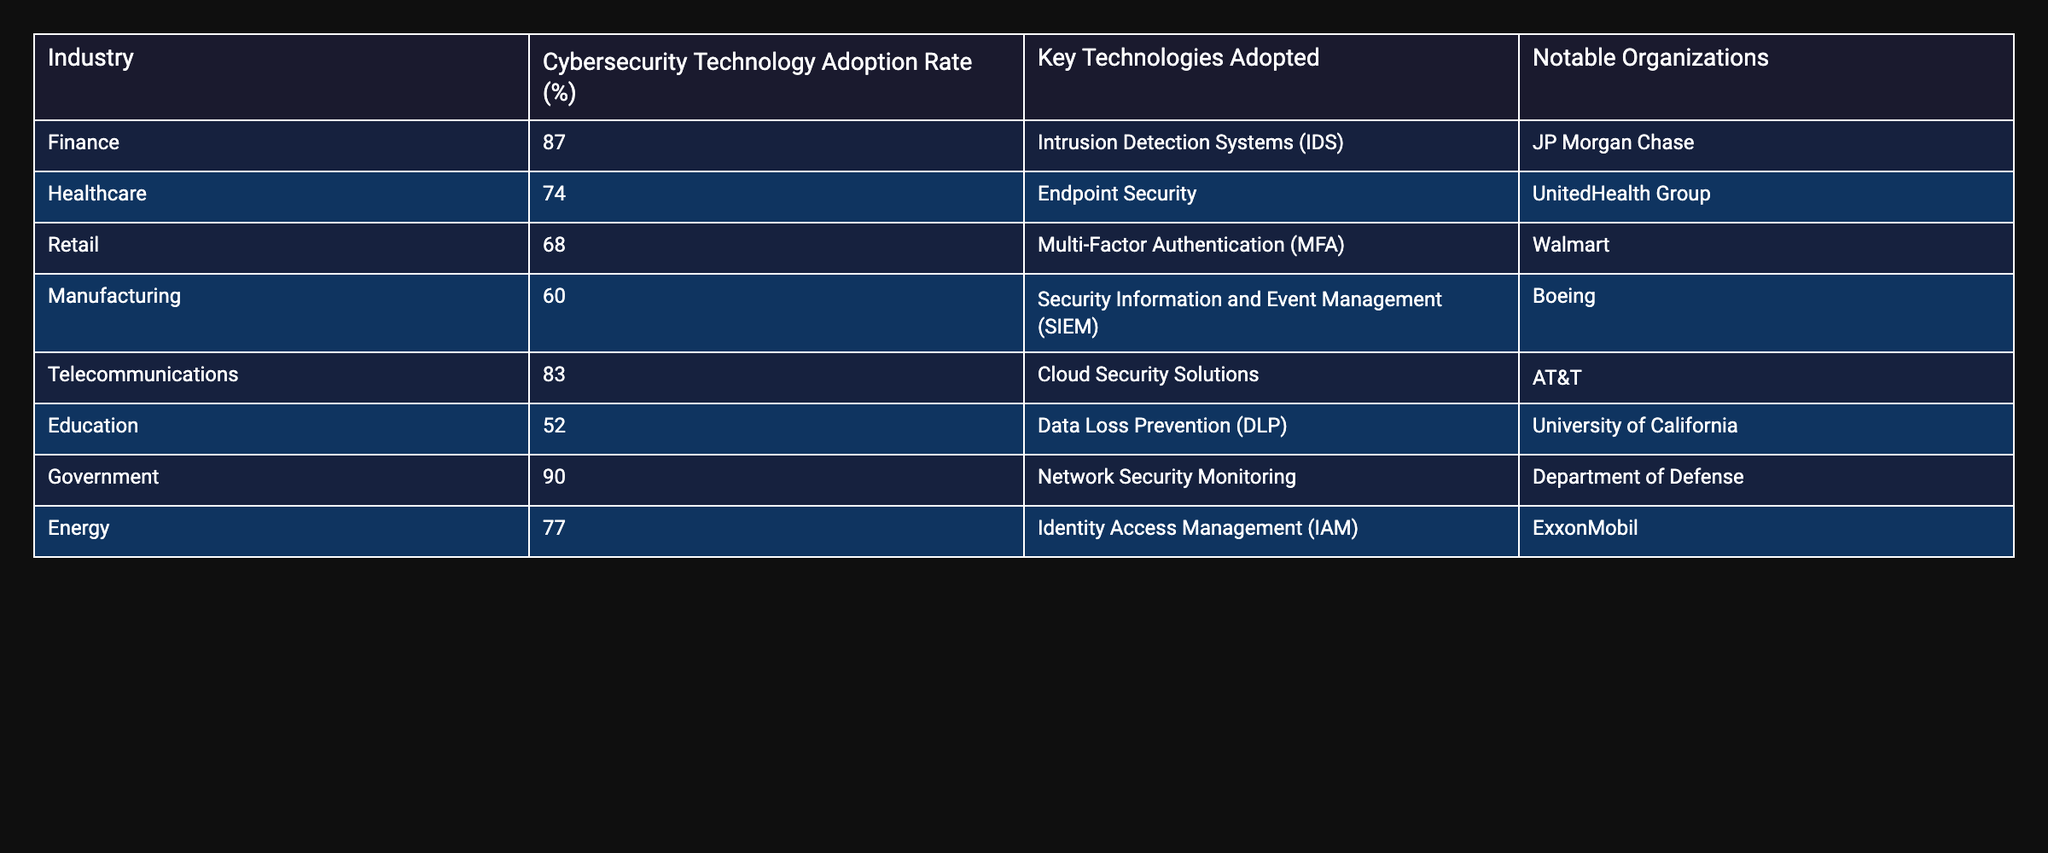What is the Cybersecurity Technology Adoption Rate for the Government industry? The table lists the adoption rate as 90% specifically for the Government industry.
Answer: 90% Which industry has the lowest Cybersecurity Technology Adoption Rate? The Education industry exhibits the lowest adoption rate at 52%, as shown by the data in the table.
Answer: 52% What is the average Cybersecurity Technology Adoption Rate across all industries listed? To calculate the average, sum the adoption rates: (87 + 74 + 68 + 60 + 83 + 52 + 90 + 77) = 601. There are 8 industries, so the average is 601 divided by 8, which equals 75.125.
Answer: 75.125 Is the use of Multi-Factor Authentication (MFA) more common in the Retail industry than Endpoint Security in Healthcare? The Retail industry has a 68% adoption rate for MFA, while Healthcare has a 74% adoption rate for Endpoint Security. Thus, it is false that MFA is more common than Endpoint Security in Healthcare.
Answer: No How many industries have an adoption rate above 80%? By examining the table, the Finance (87%), Telecommunications (83%), and Government (90%) industries have rates above 80%. Therefore, there are three industries.
Answer: 3 Which industry adopted Security Information and Event Management (SIEM) technology? The Manufacturing industry has adopted Security Information and Event Management (SIEM) technology, as seen in the specific key technologies listed in the table.
Answer: Manufacturing What percentage difference in Cybersecurity Technology Adoption Rate exists between Finance and Education? The Finance industry has a 87% adoption rate and Education has 52%. The difference is 87 - 52 = 35%. Therefore, the percentage difference is 35%.
Answer: 35% Which key technology is associated with the highest adoption rate and what is that rate? The key technology with the highest adoption rate is Network Security Monitoring, which is associated with the Government industry at a rate of 90%.
Answer: Network Security Monitoring, 90% Is Identity Access Management (IAM) used by any organization in the Finance sector? The data indicates that Identity Access Management (IAM) is implemented by ExxonMobil in the Energy sector, thus it is not utilized by any organization in the Finance sector based on the data provided.
Answer: No 